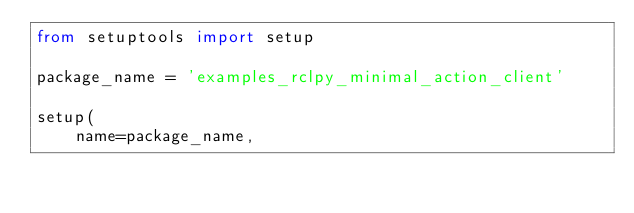<code> <loc_0><loc_0><loc_500><loc_500><_Python_>from setuptools import setup

package_name = 'examples_rclpy_minimal_action_client'

setup(
    name=package_name,</code> 